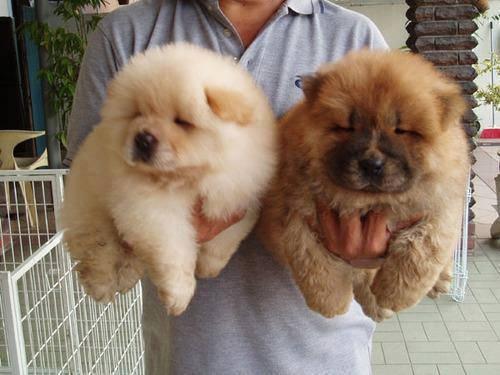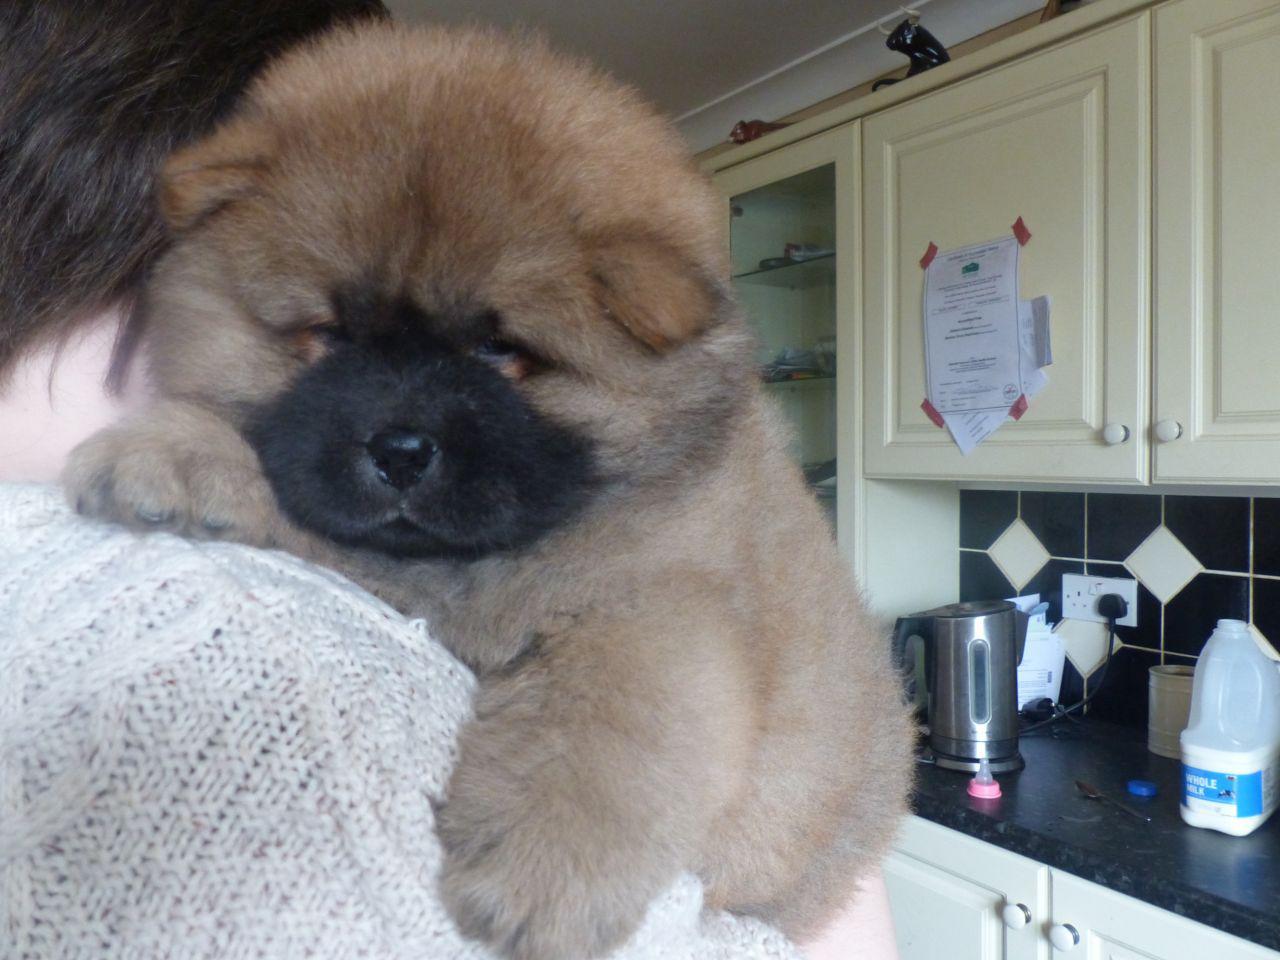The first image is the image on the left, the second image is the image on the right. Examine the images to the left and right. Is the description "There are more chow dogs in the image on the right." accurate? Answer yes or no. No. 